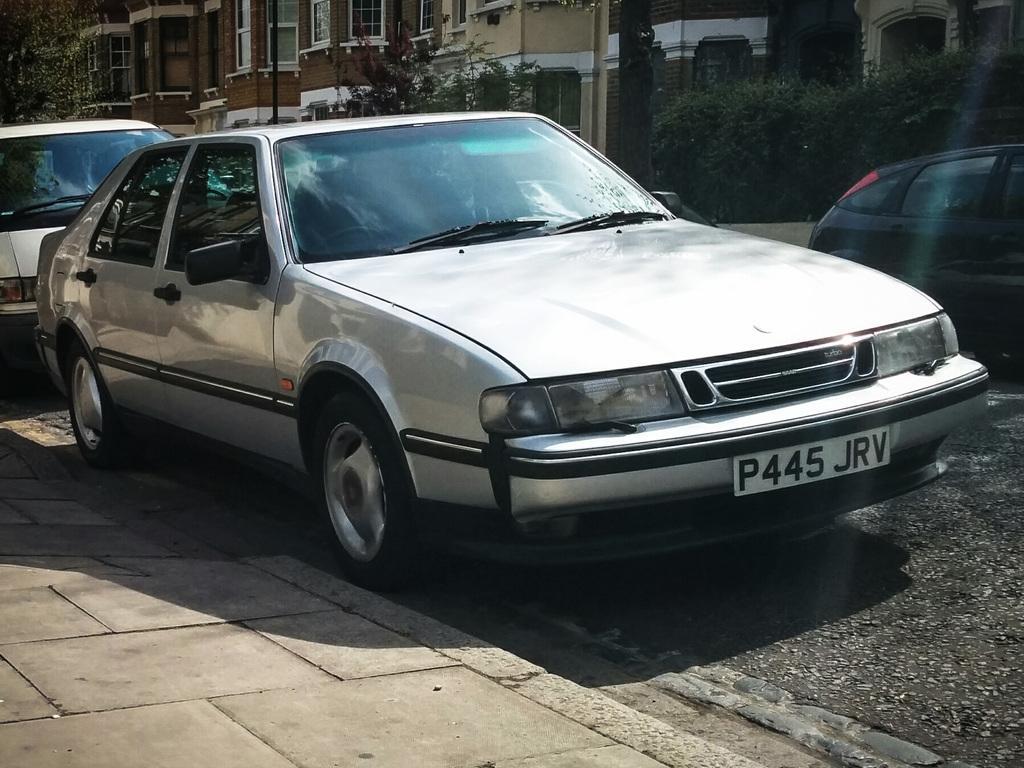Please provide a concise description of this image. In this image there is a road on that road there are vehicles, in the background there are trees and buildings. 